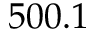<formula> <loc_0><loc_0><loc_500><loc_500>5 0 0 . 1</formula> 